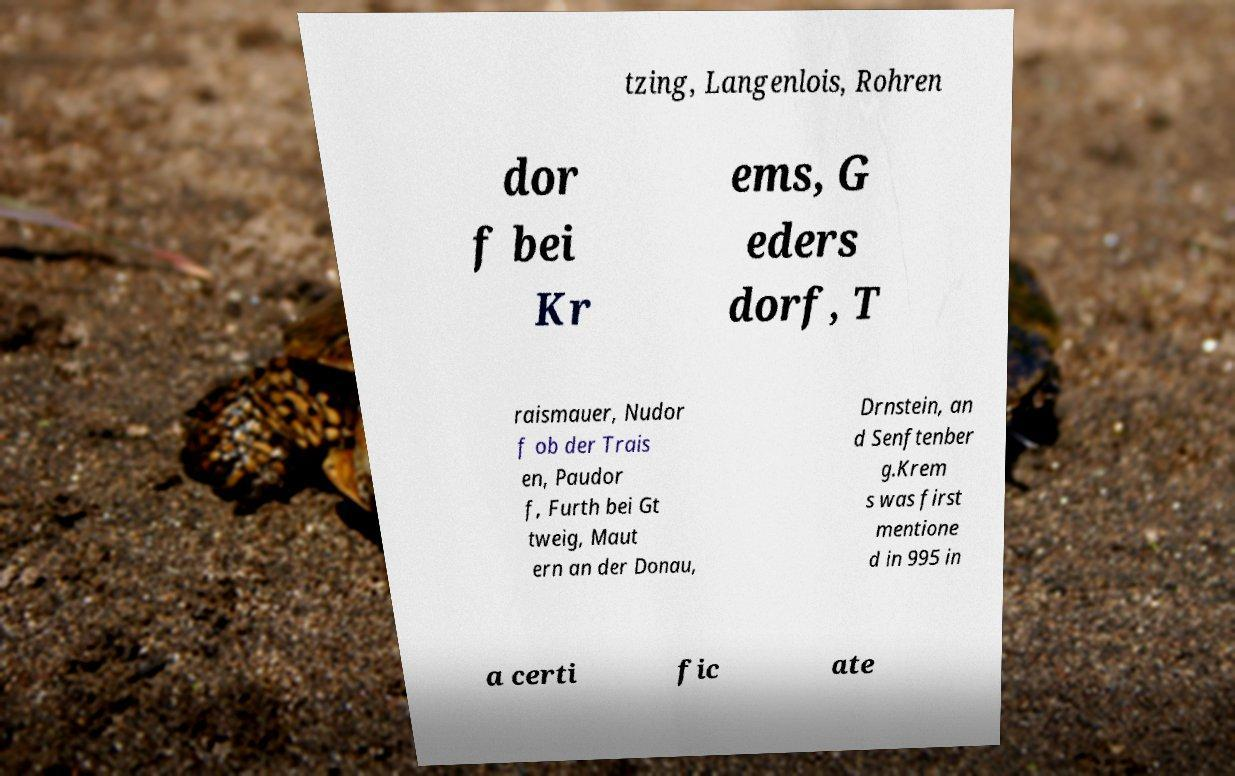There's text embedded in this image that I need extracted. Can you transcribe it verbatim? tzing, Langenlois, Rohren dor f bei Kr ems, G eders dorf, T raismauer, Nudor f ob der Trais en, Paudor f, Furth bei Gt tweig, Maut ern an der Donau, Drnstein, an d Senftenber g.Krem s was first mentione d in 995 in a certi fic ate 